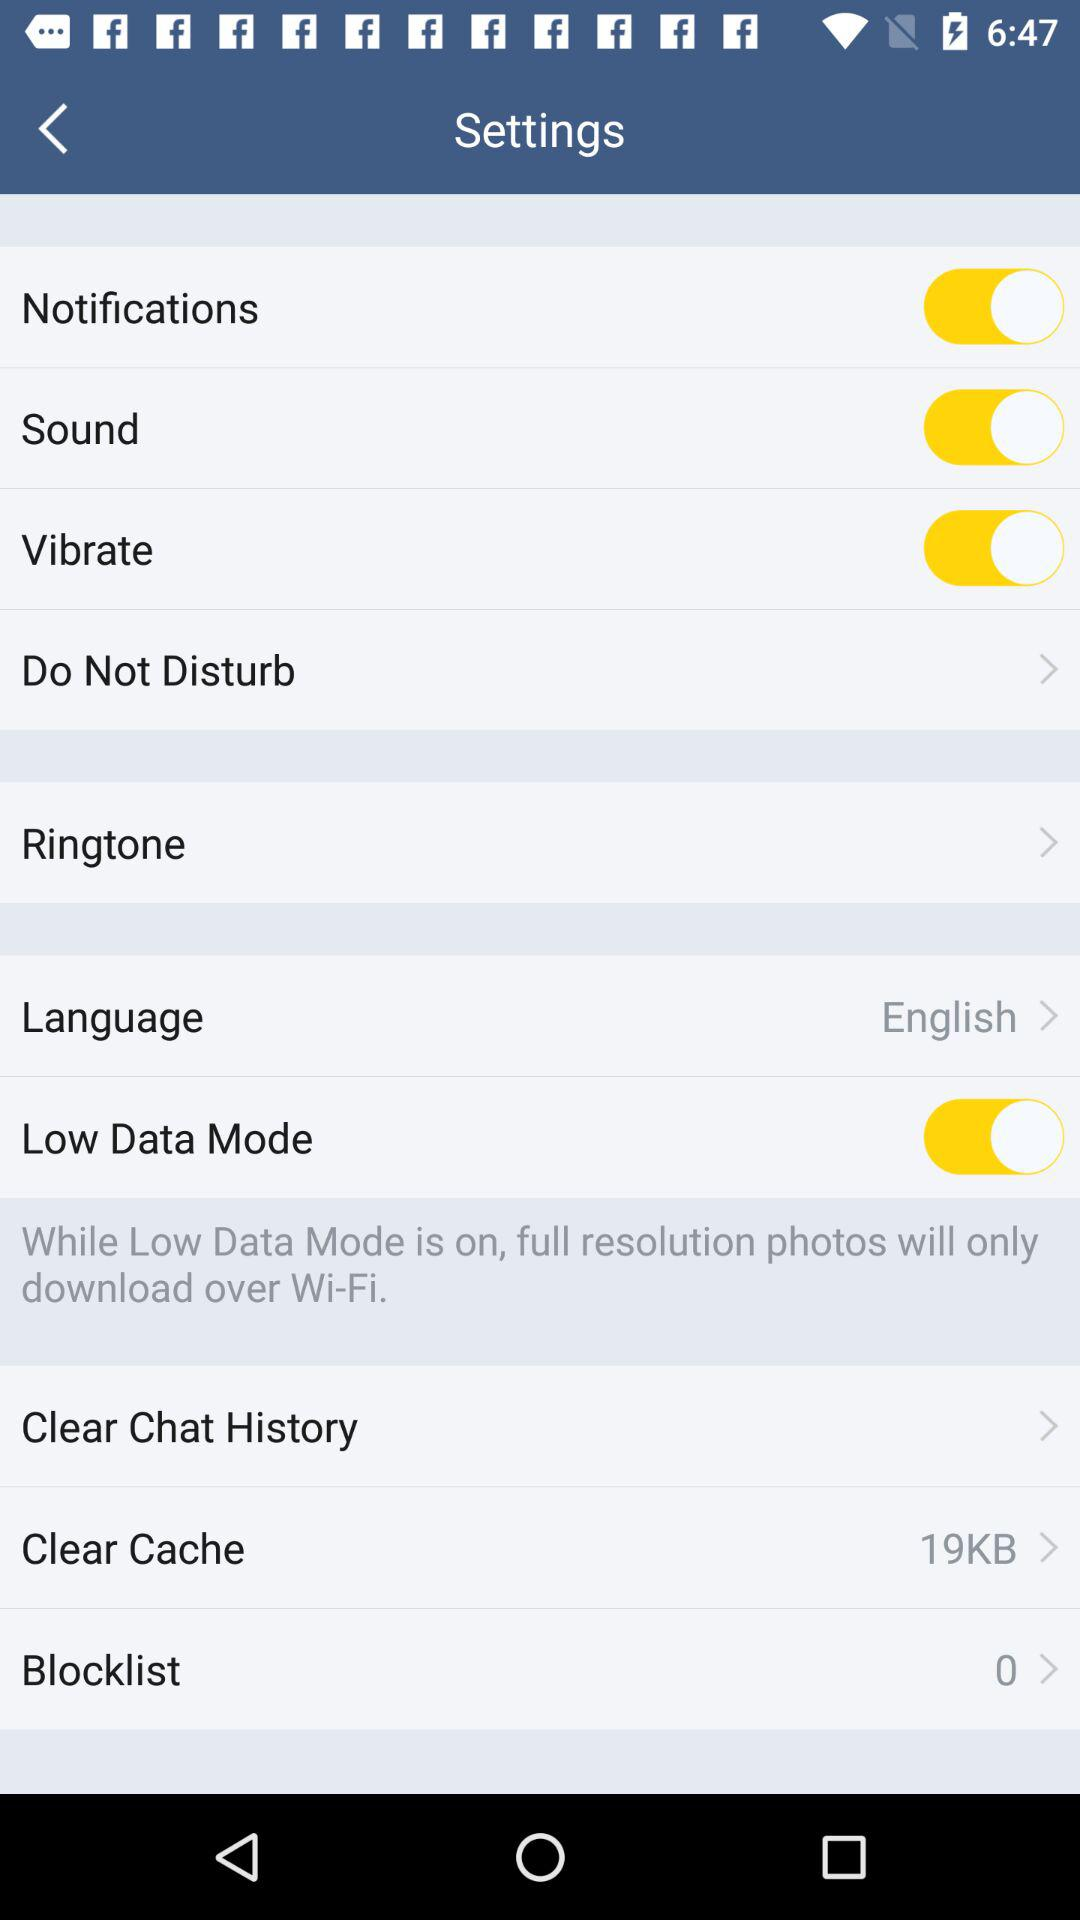What is the status of "Sound"? The status is "on". 